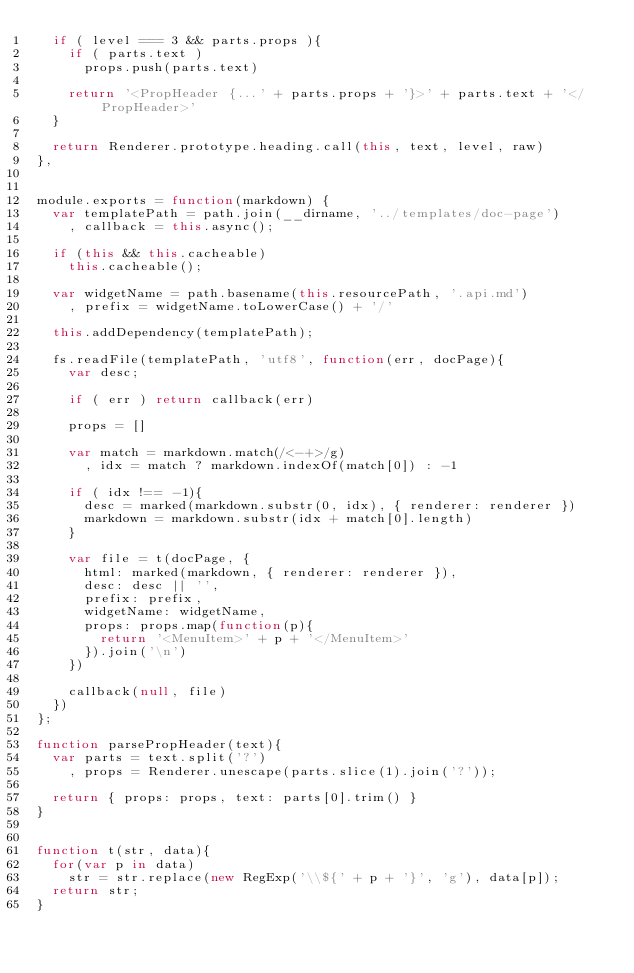<code> <loc_0><loc_0><loc_500><loc_500><_JavaScript_>  if ( level === 3 && parts.props ){
    if ( parts.text )
      props.push(parts.text)

    return '<PropHeader {...' + parts.props + '}>' + parts.text + '</PropHeader>'
  }

  return Renderer.prototype.heading.call(this, text, level, raw)
},


module.exports = function(markdown) {
  var templatePath = path.join(__dirname, '../templates/doc-page')
    , callback = this.async();

  if (this && this.cacheable)
    this.cacheable();

  var widgetName = path.basename(this.resourcePath, '.api.md')
    , prefix = widgetName.toLowerCase() + '/'

  this.addDependency(templatePath);

  fs.readFile(templatePath, 'utf8', function(err, docPage){
    var desc;

    if ( err ) return callback(err)

    props = []

    var match = markdown.match(/<-+>/g)
      , idx = match ? markdown.indexOf(match[0]) : -1

    if ( idx !== -1){
      desc = marked(markdown.substr(0, idx), { renderer: renderer })
      markdown = markdown.substr(idx + match[0].length)
    }

    var file = t(docPage, {
      html: marked(markdown, { renderer: renderer }),
      desc: desc || '',
      prefix: prefix,
      widgetName: widgetName,
      props: props.map(function(p){
        return '<MenuItem>' + p + '</MenuItem>'
      }).join('\n')
    })

    callback(null, file)
  })
};

function parsePropHeader(text){
  var parts = text.split('?')
    , props = Renderer.unescape(parts.slice(1).join('?'));

  return { props: props, text: parts[0].trim() }
}


function t(str, data){
  for(var p in data)
    str = str.replace(new RegExp('\\${' + p + '}', 'g'), data[p]);
  return str;
}
</code> 